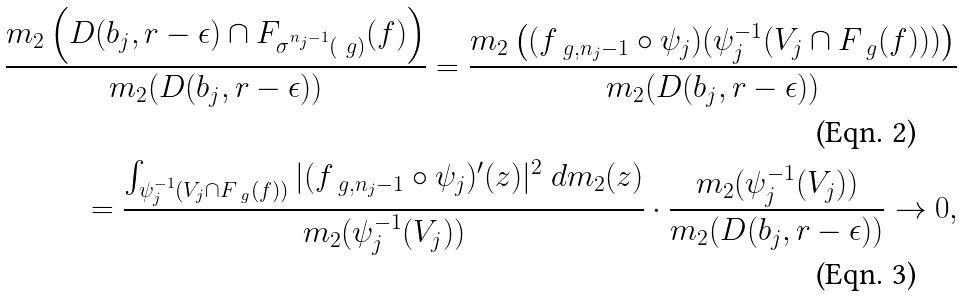Convert formula to latex. <formula><loc_0><loc_0><loc_500><loc_500>\frac { m _ { 2 } \left ( D ( b _ { j } , r - \epsilon ) \cap F _ { \sigma ^ { n _ { j } - 1 } ( \ g ) } ( f ) \right ) } { m _ { 2 } ( D ( b _ { j } , r - \epsilon ) ) } = \frac { m _ { 2 } \left ( ( f _ { \ g , n _ { j } - 1 } \circ \psi _ { j } ) ( \psi _ { j } ^ { - 1 } ( V _ { j } \cap F _ { \ g } ( f ) ) ) \right ) } { m _ { 2 } ( D ( b _ { j } , r - \epsilon ) ) } \\ = \frac { \int _ { \psi _ { j } ^ { - 1 } ( V _ { j } \cap F _ { \ g } ( f ) ) } | ( f _ { \ g , n _ { j } - 1 } \circ \psi _ { j } ) ^ { \prime } ( z ) | ^ { 2 } \ d m _ { 2 } ( z ) } { m _ { 2 } ( \psi _ { j } ^ { - 1 } ( V _ { j } ) ) } \cdot \frac { m _ { 2 } ( \psi _ { j } ^ { - 1 } ( V _ { j } ) ) } { m _ { 2 } ( D ( b _ { j } , r - \epsilon ) ) } \rightarrow 0 ,</formula> 